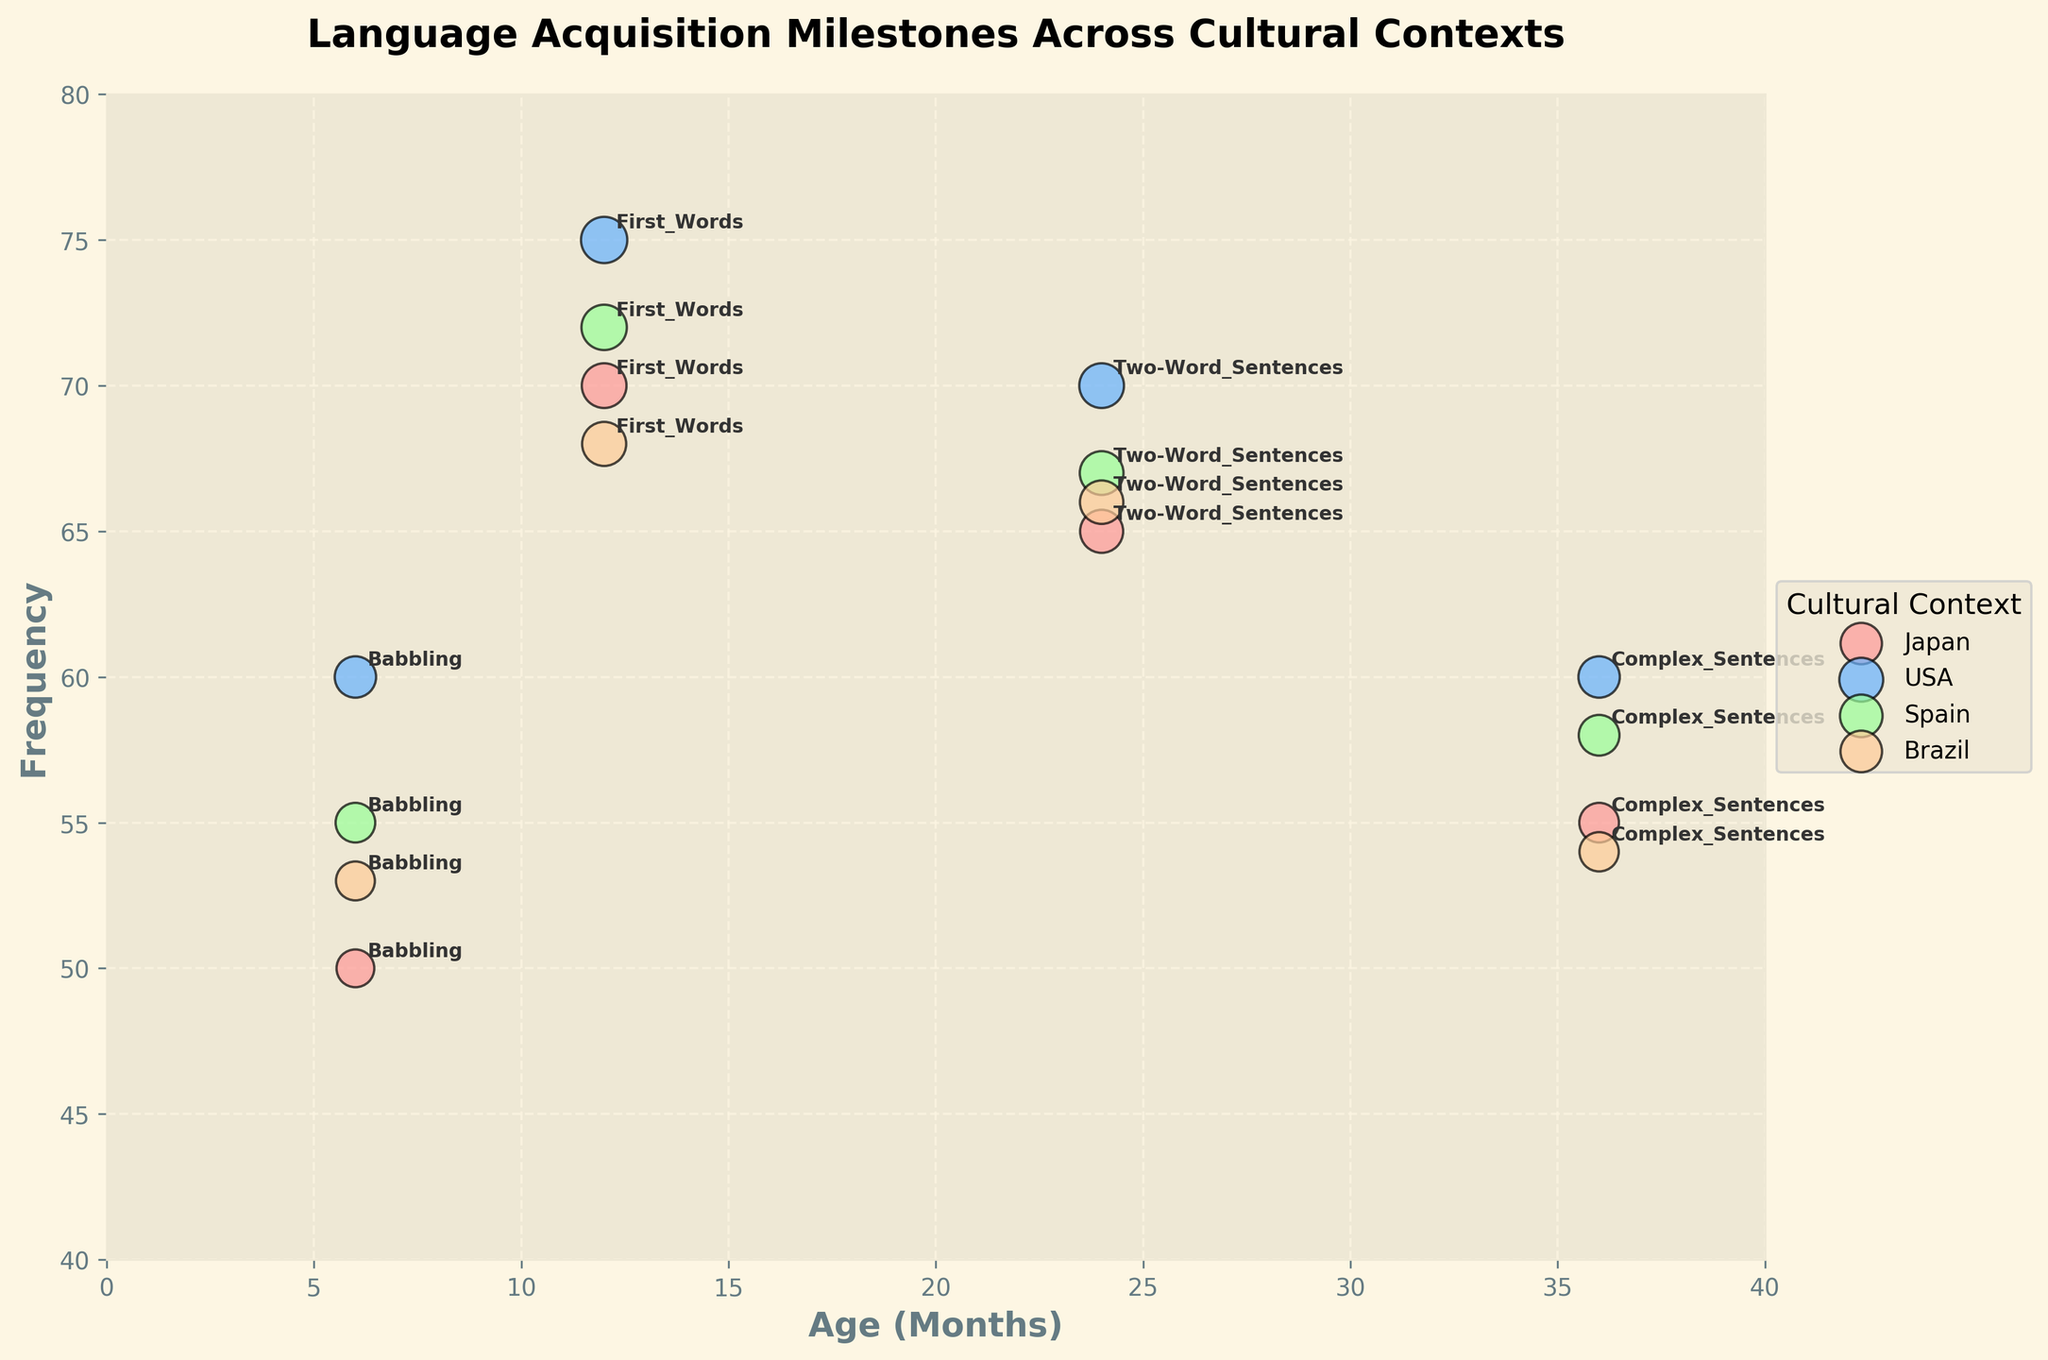What are the age ranges represented on the x-axis of the plot? The x-axis shows the age in months, ranging from 0 to 40 months as indicated by the limits on the axis.
Answer: 0 to 40 months What is the title of the plot? The title of the plot is displayed at the top of the figure and reads "Language Acquisition Milestones Across Cultural Contexts".
Answer: Language Acquisition Milestones Across Cultural Contexts Which cultural context shows the highest frequency at the Babbling milestone? To determine this, look at the Babbling milestone (Age 6 months) data points and compare their frequency values. The USA has a frequency of 60, the highest among Japan, USA, Spain, and Brazil.
Answer: USA What is the average frequency size for the First Words milestone across all cultural contexts? Sum the frequency sizes for the First Words milestone across Japan, USA, Spain, and Brazil: 70 + 75 + 72 + 68 = 285. Divide the sum by the number of contexts, which is 4. Therefore, the average is 285 / 4.
Answer: 71.25 Which milestone appears at Age 36 months for the Brazilian cultural context, and what is its frequency? Find the data point for Brazil at Age 36 months. The milestone is Complex Sentences with a frequency of 54.
Answer: Complex Sentences, 54 Between Japan and Spain, which cultural context shows a higher frequency for the Two-Word Sentences milestone? Compare the frequency values for Japan and Spain at Age 24 months (Two-Word Sentences milestone). Japan has a frequency of 65, whereas Spain has a frequency of 67. Hence, Spain has a higher frequency.
Answer: Spain What is the combined frequency size for the Complex Sentences milestone across Japan and the USA? Add the frequency sizes for the Complex Sentences milestone for both Japan and the USA: 55 (Japan) + 60 (USA).
Answer: 115 Which cultural context has a smaller marker size for the First Words milestone, Brazil or Japan? Marker size corresponds to frequency size, so compare the frequency sizes for Brazil (68) and Japan (70) at Age 12 months. Brazil has a smaller marker size.
Answer: Brazil At Age 36 months, which cultural context has the lowest frequency for language acquisition milestones? Look at the data points for Age 36 months and compare their frequencies. Brazil has the lowest frequency at 54.
Answer: Brazil 